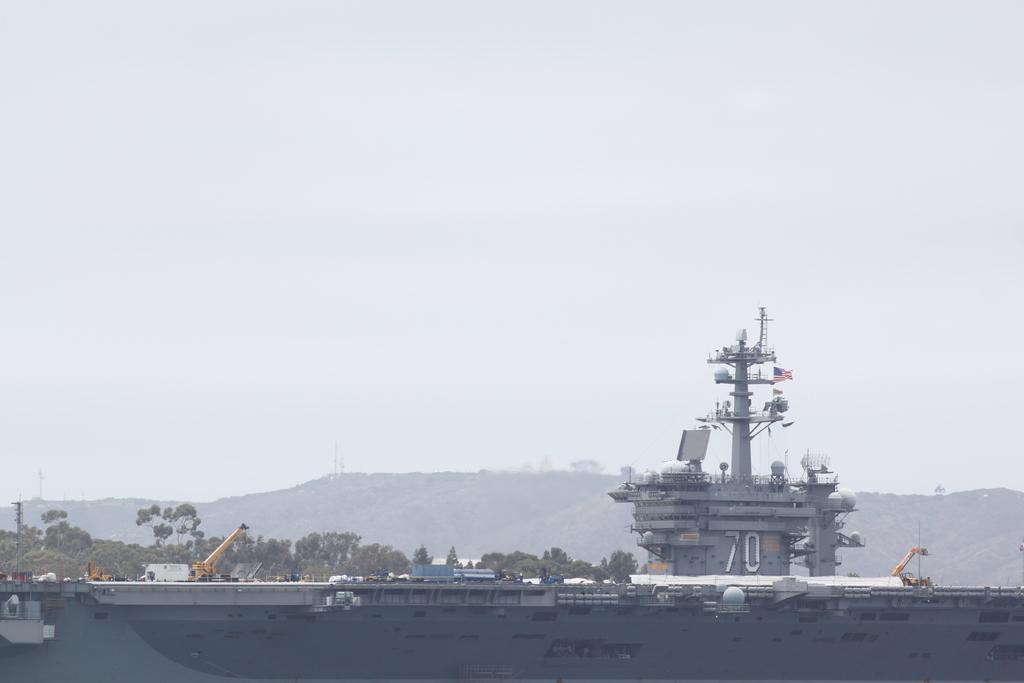Could you give a brief overview of what you see in this image? At the bottom of the image we can see a ship and there are cranes. In the background there are trees, hills and sky. 